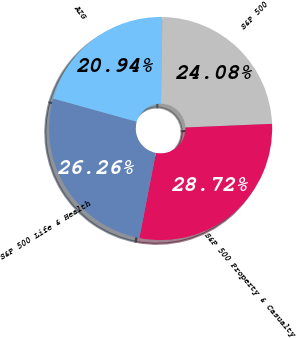Convert chart. <chart><loc_0><loc_0><loc_500><loc_500><pie_chart><fcel>AIG<fcel>S&P 500<fcel>S&P 500 Property & Casualty<fcel>S&P 500 Life & Health<nl><fcel>20.94%<fcel>24.08%<fcel>28.72%<fcel>26.26%<nl></chart> 